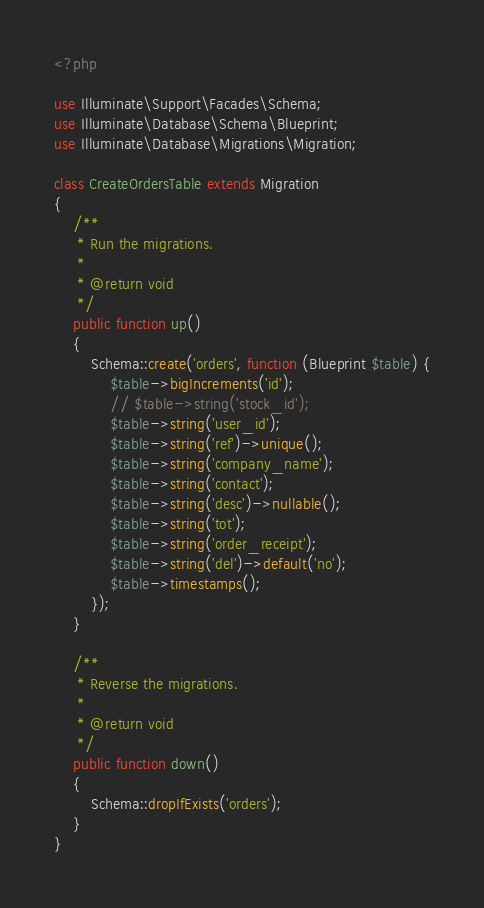<code> <loc_0><loc_0><loc_500><loc_500><_PHP_><?php

use Illuminate\Support\Facades\Schema;
use Illuminate\Database\Schema\Blueprint;
use Illuminate\Database\Migrations\Migration;

class CreateOrdersTable extends Migration
{
    /**
     * Run the migrations.
     *
     * @return void
     */
    public function up()
    {
        Schema::create('orders', function (Blueprint $table) {
            $table->bigIncrements('id');
            // $table->string('stock_id');
            $table->string('user_id');
            $table->string('ref')->unique();
            $table->string('company_name');
            $table->string('contact');
            $table->string('desc')->nullable();
            $table->string('tot');
            $table->string('order_receipt');
            $table->string('del')->default('no');
            $table->timestamps();
        });
    }

    /**
     * Reverse the migrations.
     *
     * @return void
     */
    public function down()
    {
        Schema::dropIfExists('orders');
    }
}
</code> 